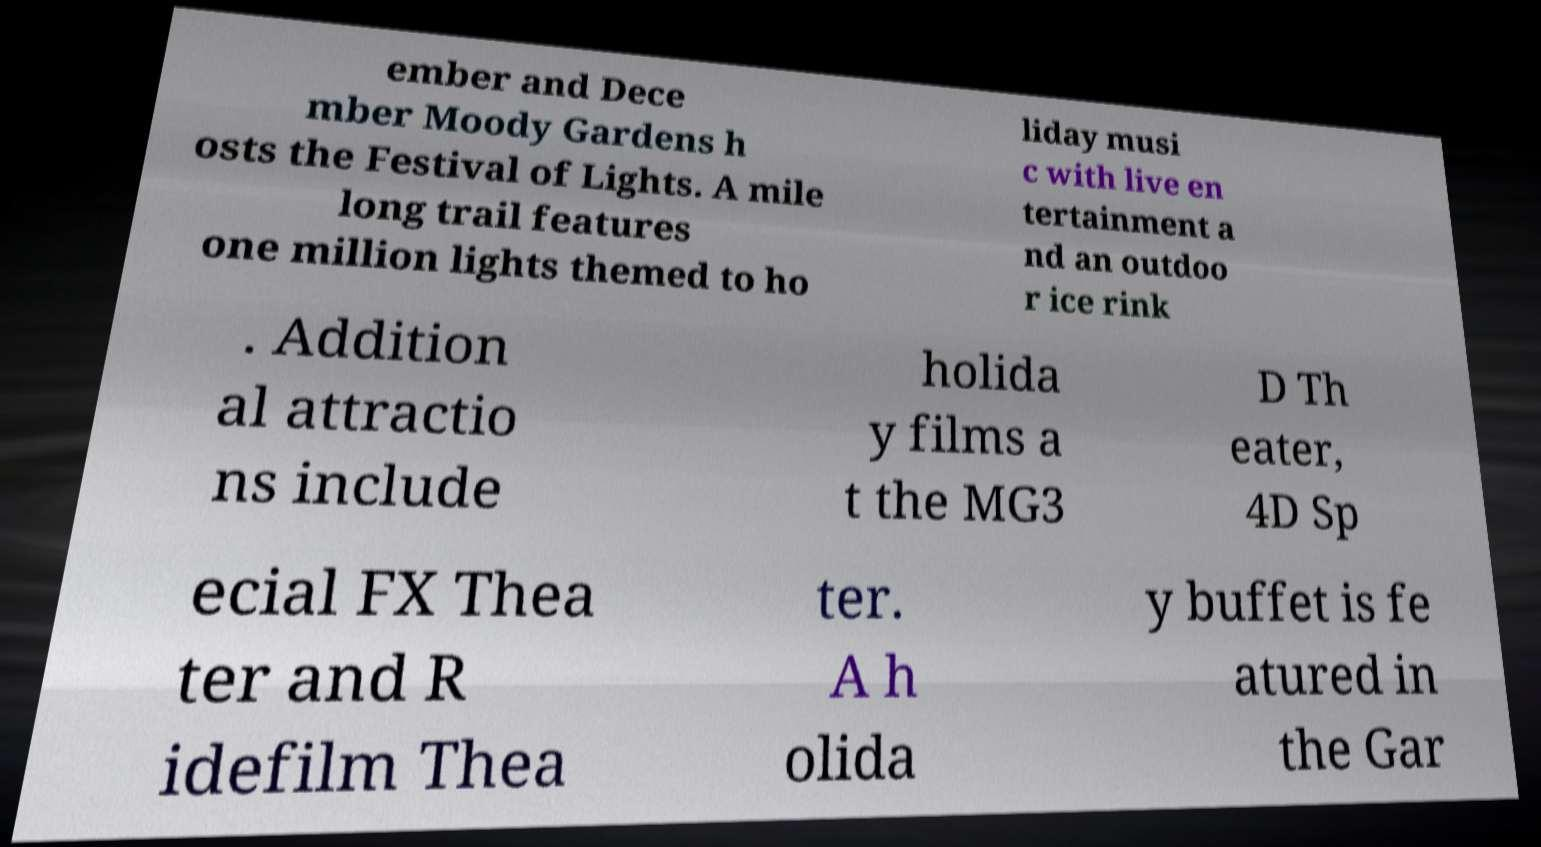Could you assist in decoding the text presented in this image and type it out clearly? ember and Dece mber Moody Gardens h osts the Festival of Lights. A mile long trail features one million lights themed to ho liday musi c with live en tertainment a nd an outdoo r ice rink . Addition al attractio ns include holida y films a t the MG3 D Th eater, 4D Sp ecial FX Thea ter and R idefilm Thea ter. A h olida y buffet is fe atured in the Gar 